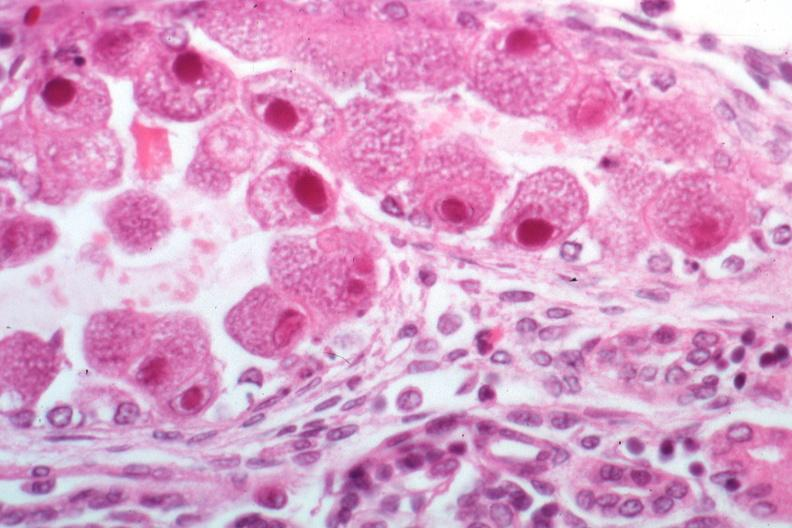what is present?
Answer the question using a single word or phrase. Cytomegalovirus 